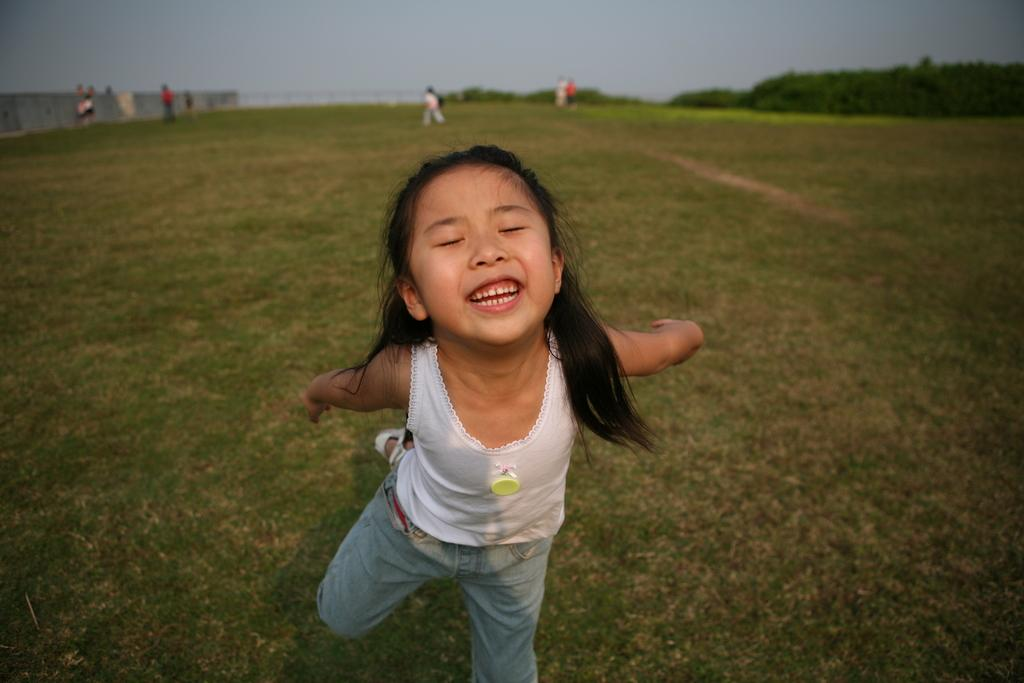What is the main subject in the foreground of the image? There is a girl in the foreground of the image. What is the girl doing in the image? The girl is standing on one leg and has her eyes closed. What can be seen in the background of the image? There are persons, railing, trees, and the sky visible in the background of the image. Can you tell me what type of ocean is visible in the image? There is no ocean present in the image; it features a girl standing on one leg with her eyes closed and a background that includes persons, railing, trees, and the sky. 